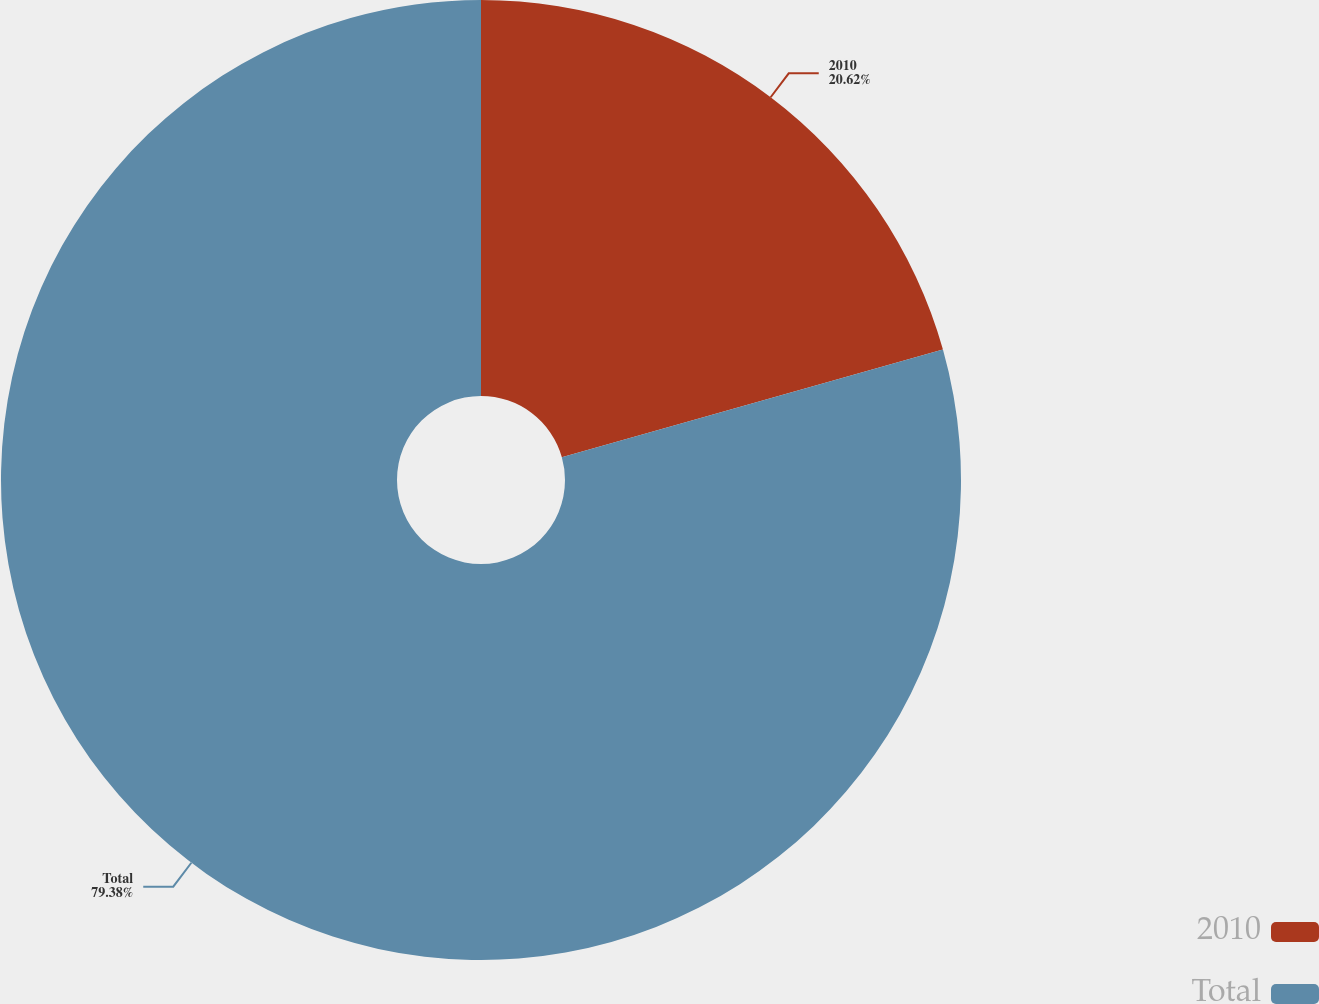<chart> <loc_0><loc_0><loc_500><loc_500><pie_chart><fcel>2010<fcel>Total<nl><fcel>20.62%<fcel>79.38%<nl></chart> 